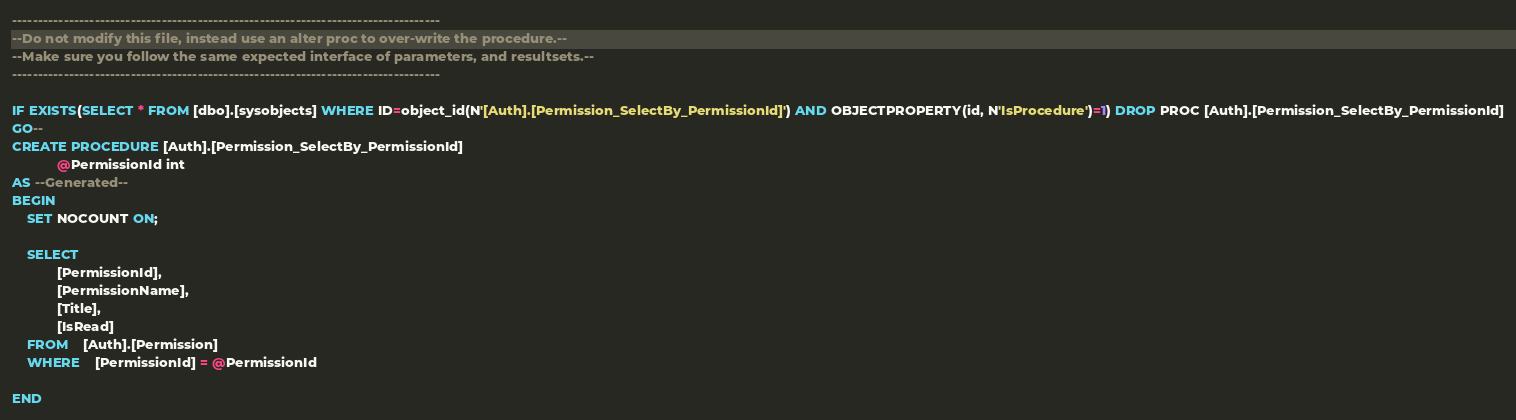Convert code to text. <code><loc_0><loc_0><loc_500><loc_500><_SQL_>-----------------------------------------------------------------------------------
--Do not modify this file, instead use an alter proc to over-write the procedure.--
--Make sure you follow the same expected interface of parameters, and resultsets.--
-----------------------------------------------------------------------------------

IF EXISTS(SELECT * FROM [dbo].[sysobjects] WHERE ID=object_id(N'[Auth].[Permission_SelectBy_PermissionId]') AND OBJECTPROPERTY(id, N'IsProcedure')=1) DROP PROC [Auth].[Permission_SelectBy_PermissionId]
GO--
CREATE PROCEDURE [Auth].[Permission_SelectBy_PermissionId] 
			@PermissionId int
AS --Generated--
BEGIN
	SET NOCOUNT ON;

	SELECT	
			[PermissionId],
			[PermissionName],
			[Title],
			[IsRead]
	FROM	[Auth].[Permission]
	WHERE	[PermissionId] = @PermissionId

END</code> 